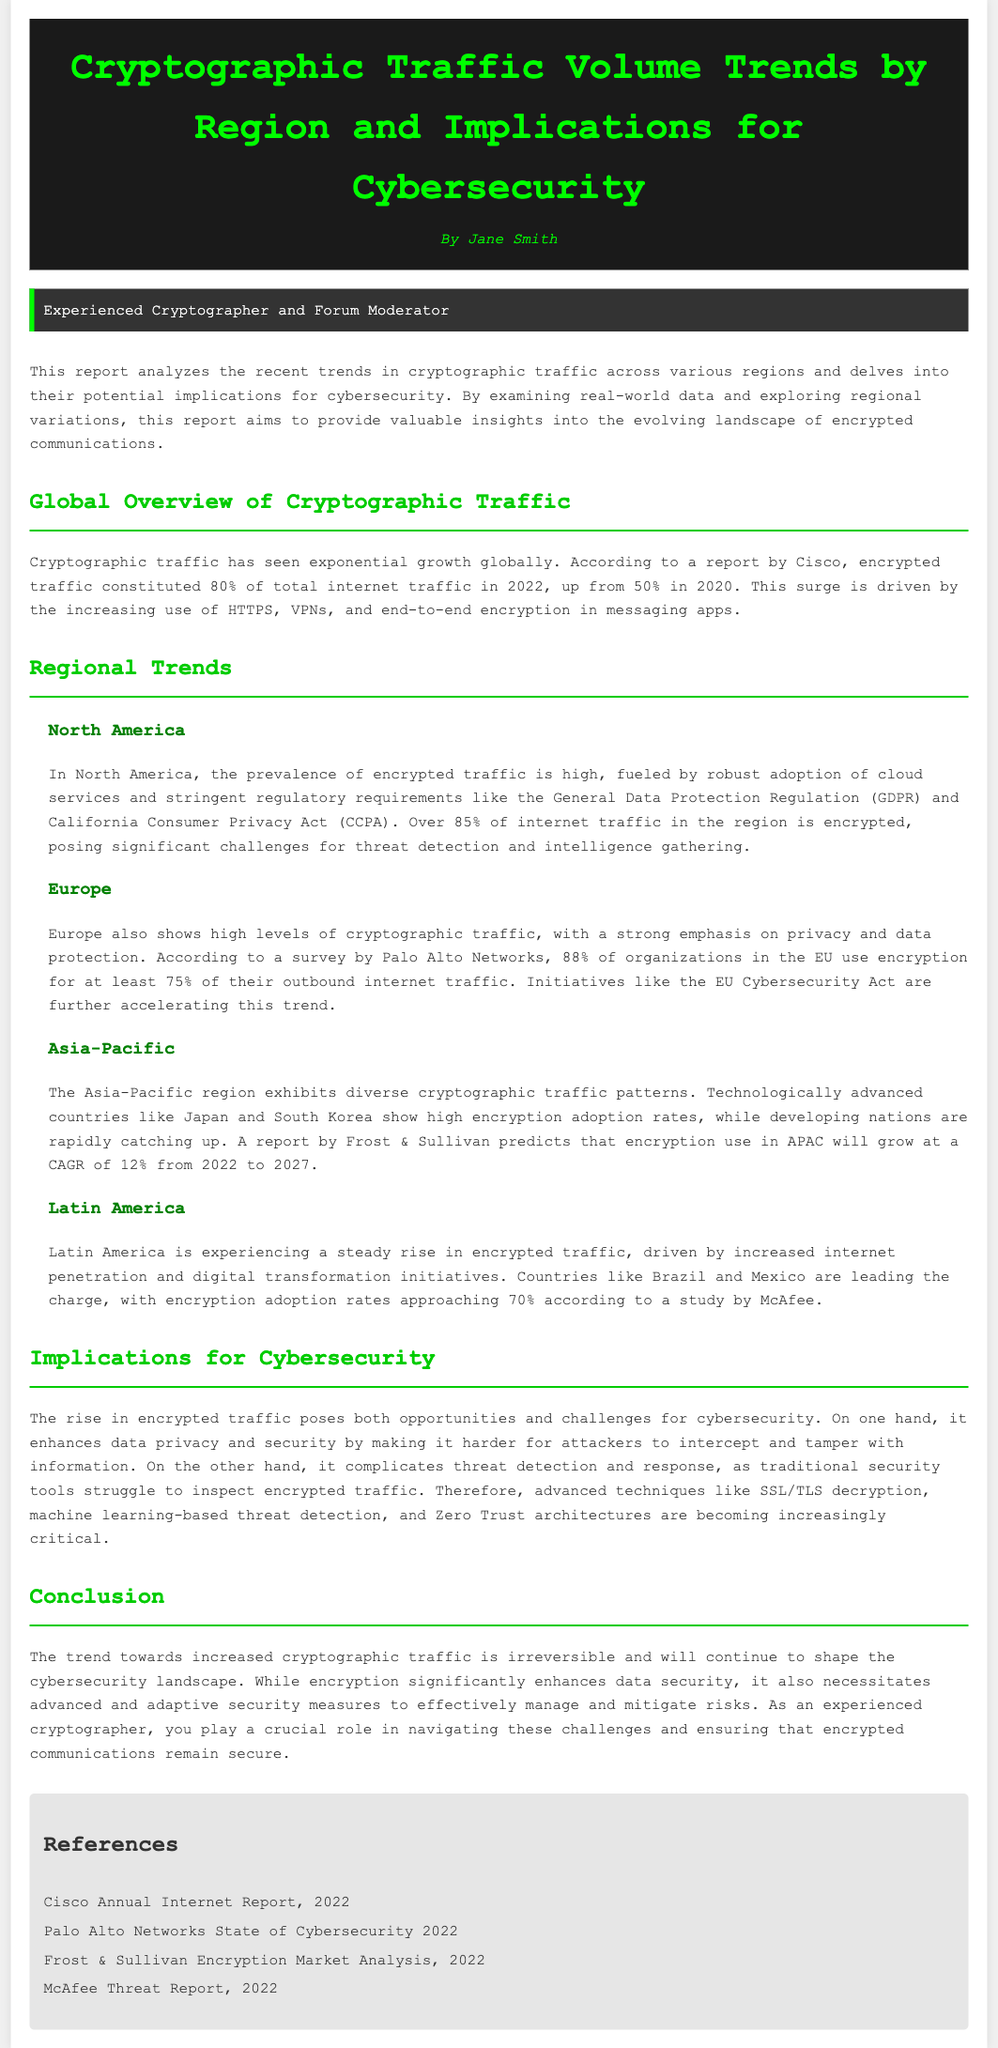What percentage of global internet traffic was encrypted in 2022? The report states that encrypted traffic constituted 80% of total internet traffic in 2022.
Answer: 80% Which region has the highest percentage of encrypted internet traffic? North America is noted to have over 85% of internet traffic encrypted.
Answer: North America What regulatory act is mentioned in relation to North America’s encrypted traffic? The General Data Protection Regulation (GDPR) and California Consumer Privacy Act (CCPA) are highlighted in the report.
Answer: GDPR and CCPA What is the predicted growth rate for encryption use in the Asia-Pacific region from 2022 to 2027? A report predicts that encryption use in APAC will grow at a CAGR of 12% during that period.
Answer: 12% Which countries in Latin America are leading in encryption adoption according to the study? Brazil and Mexico are mentioned as leading in encryption adoption rates.
Answer: Brazil and Mexico What cybersecurity strategy is becoming increasingly critical due to rising encrypted traffic? Advanced techniques like SSL/TLS decryption are being emphasized for managing encrypted traffic.
Answer: SSL/TLS decryption What is the primary challenge posed by the rise in encrypted traffic for cybersecurity? The rise complicates threat detection and response for traditional security tools.
Answer: Threat detection and response What percentage of organizations in the EU use encryption for at least 75% of their outbound internet traffic? According to a survey by Palo Alto Networks, 88% of organizations in the EU use encryption for this purpose.
Answer: 88% What is the primary benefit of the increase in cryptographic traffic? The primary benefit is enhanced data privacy and security.
Answer: Enhanced data privacy and security 